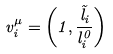<formula> <loc_0><loc_0><loc_500><loc_500>v _ { i } ^ { \mu } = \left ( 1 , \frac { \vec { l } _ { i } } { l _ { i } ^ { 0 } } \right )</formula> 